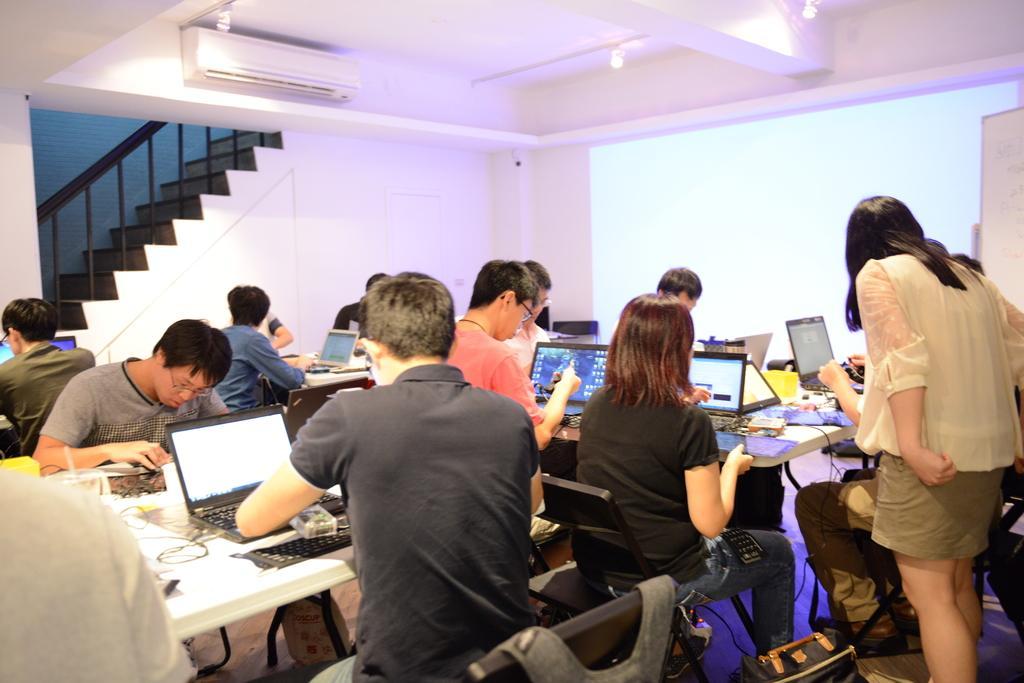How would you summarize this image in a sentence or two? In the right side a beautiful girl is standing, beside her another girl is sitting on the chair, working in the laptop. On the left side a man is sitting on the chair. He wore black color t-shirt. In the middle this is the A. C. and on it is a staircase. 